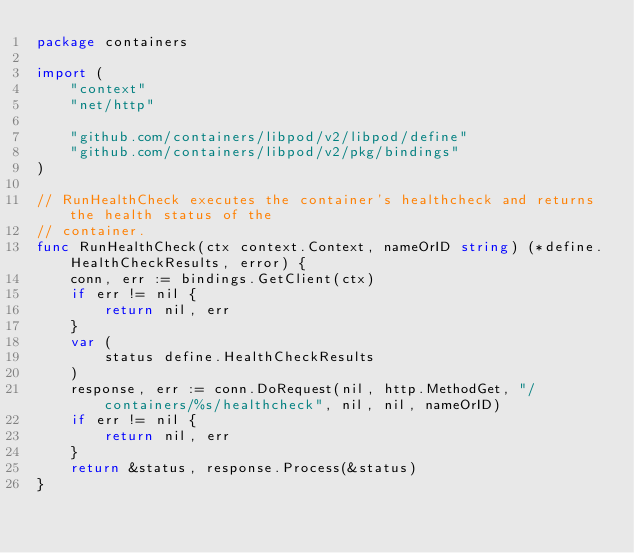<code> <loc_0><loc_0><loc_500><loc_500><_Go_>package containers

import (
	"context"
	"net/http"

	"github.com/containers/libpod/v2/libpod/define"
	"github.com/containers/libpod/v2/pkg/bindings"
)

// RunHealthCheck executes the container's healthcheck and returns the health status of the
// container.
func RunHealthCheck(ctx context.Context, nameOrID string) (*define.HealthCheckResults, error) {
	conn, err := bindings.GetClient(ctx)
	if err != nil {
		return nil, err
	}
	var (
		status define.HealthCheckResults
	)
	response, err := conn.DoRequest(nil, http.MethodGet, "/containers/%s/healthcheck", nil, nil, nameOrID)
	if err != nil {
		return nil, err
	}
	return &status, response.Process(&status)
}
</code> 